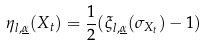Convert formula to latex. <formula><loc_0><loc_0><loc_500><loc_500>\eta _ { l , \underline { \alpha } } ( X _ { t } ) = \frac { 1 } { 2 } ( \xi _ { l , \underline { \alpha } } ( \sigma _ { X _ { t } } ) - 1 )</formula> 